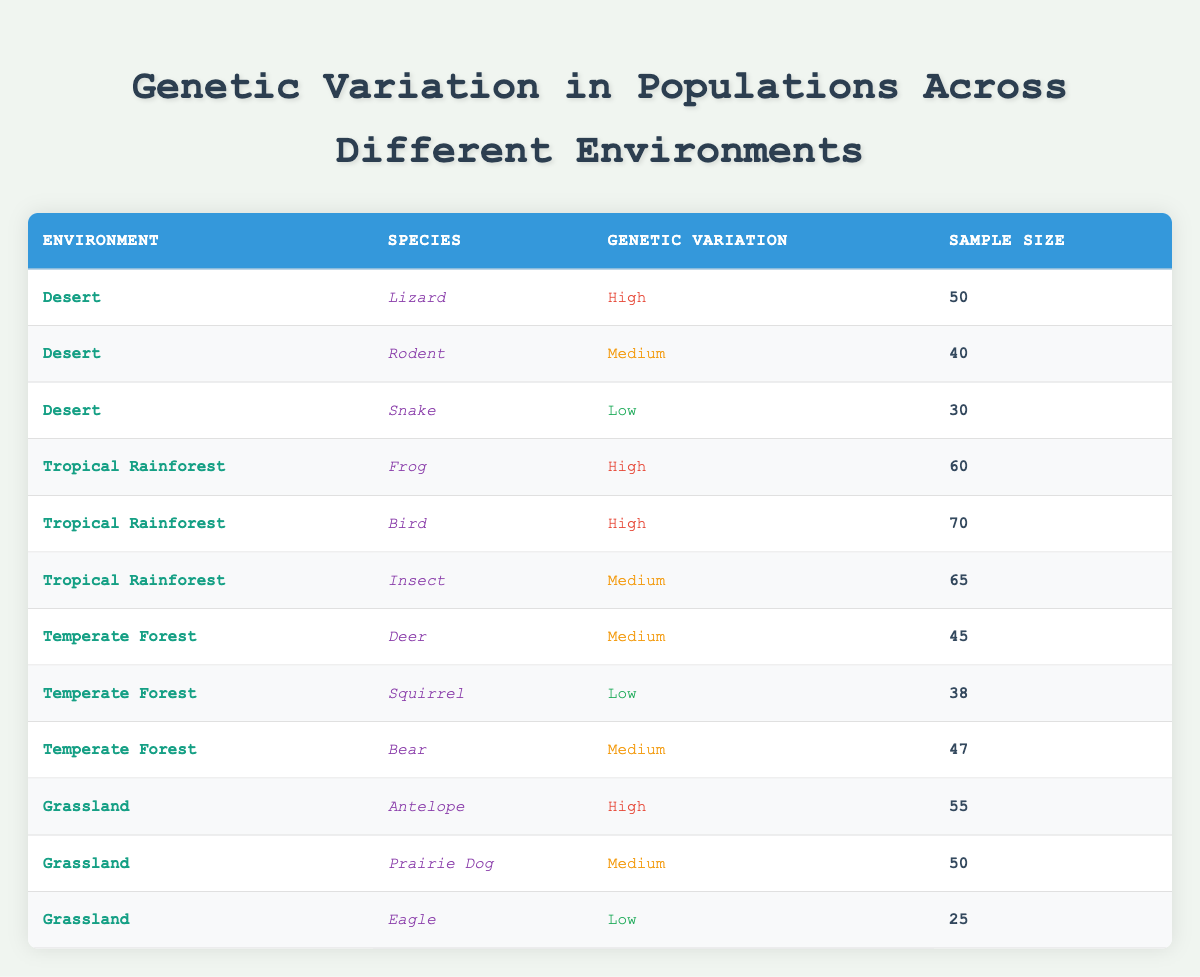What species in the Desert environment has the highest genetic variation? The table indicates that in the Desert environment, the Lizard has the highest genetic variation categorized as high, with a sample size of 50.
Answer: Lizard How many species in the Tropical Rainforest have high genetic variation? Upon examining the Tropical Rainforest section of the table, there are two species listed with high genetic variation: Frog and Bird.
Answer: 2 What is the total sample size of all species found in Grassland? To calculate the total sample size for Grassland, we sum the sample sizes of Antelope (55), Prairie Dog (50), and Eagle (25). Thus, 55 + 50 + 25 = 130.
Answer: 130 Does the Temperate Forest environment have any species with low genetic variation? Yes, the table shows that within the Temperate Forest, the species Squirrel is listed with low genetic variation.
Answer: Yes Which environment has the lowest average sample size across its species? To find the environment with the lowest average sample size, we calculate the averages: Desert (40), Tropical Rainforest (65), Temperate Forest (43), and Grassland (43.33). The Desert with an average of 40 is the lowest.
Answer: Desert How many more species in the Tropical Rainforest have high genetic variation than in the Grassland? The Tropical Rainforest has 2 species with high variation (Frog and Bird), while the Grassland has 1 (Antelope). Therefore, the difference is 2 - 1 = 1.
Answer: 1 What is the genetic variation of the species with the largest sample size in the table? The species with the largest sample size is Bird from the Tropical Rainforest, which has high genetic variation.
Answer: High Is there a species in the Temperate Forest with high genetic variation? The data shows that all species listed in the Temperate Forest have either medium or low genetic variation, confirming there are no species with high genetic variation.
Answer: No What fraction of species in Grassland has low genetic variation? There are 3 species in Grassland (Antelope, Prairie Dog, Eagle) and 1 of them (Eagle) has low genetic variation. The fraction is 1 out of 3, which simplifies to 1/3.
Answer: 1/3 